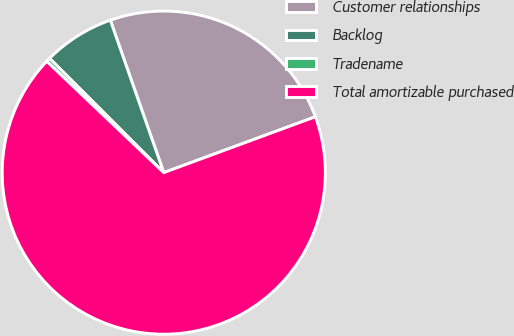Convert chart to OTSL. <chart><loc_0><loc_0><loc_500><loc_500><pie_chart><fcel>Customer relationships<fcel>Backlog<fcel>Tradename<fcel>Total amortizable purchased<nl><fcel>24.75%<fcel>7.13%<fcel>0.4%<fcel>67.73%<nl></chart> 